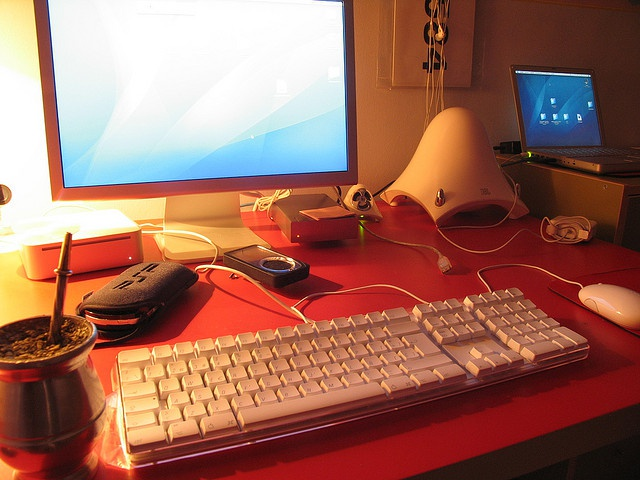Describe the objects in this image and their specific colors. I can see tv in khaki, white, lightblue, and orange tones, keyboard in khaki, tan, brown, and maroon tones, laptop in khaki, blue, black, navy, and darkblue tones, cell phone in khaki, maroon, black, and brown tones, and mouse in khaki, tan, red, brown, and salmon tones in this image. 